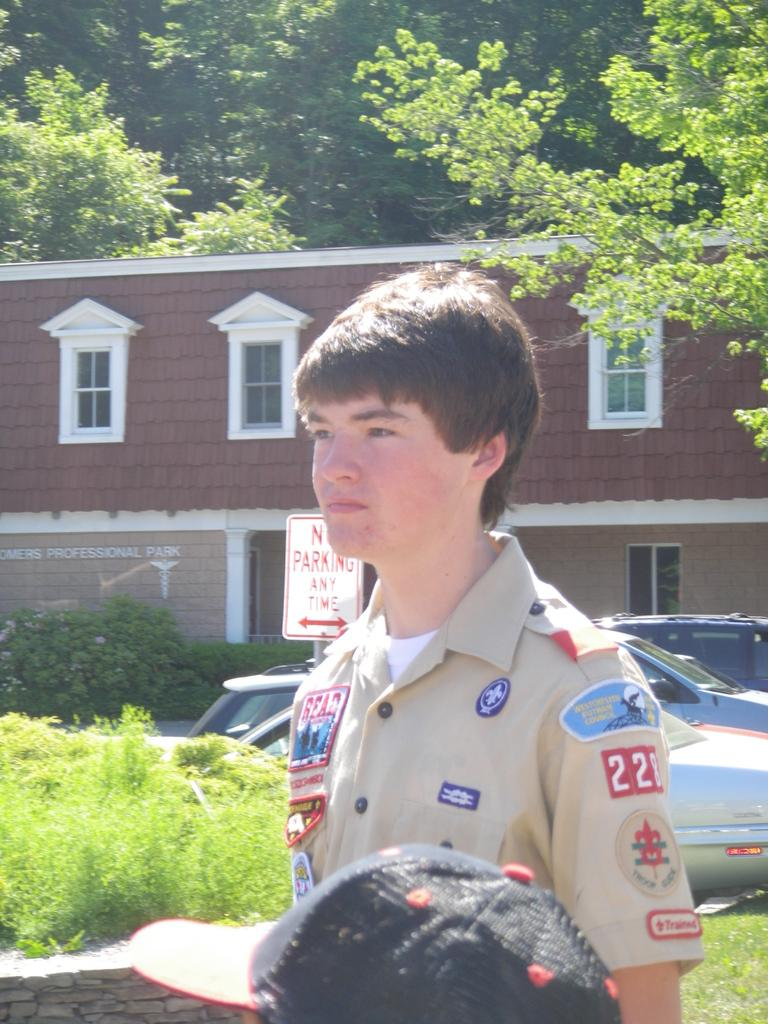Who is present in the image? There is a man in the image. What is located beside the man? There is a cap beside the man. What type of vegetation can be seen in the image? There are plants, grass, and trees in the image. What structure is visible in the image? There is a building in the image. What else can be seen in the image? There are vehicles and more trees visible in the image. What type of note is the man holding in the image? There is no note present in the image. How many quinces are visible in the image? There are no quinces present in the image. 